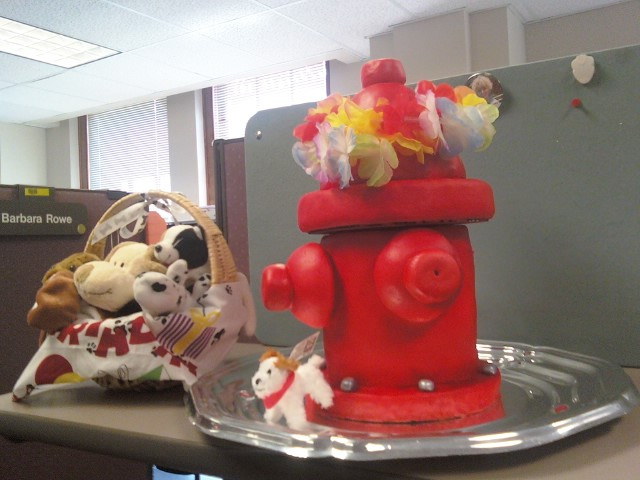Please transcribe the text in this image. Barbara Rowe 